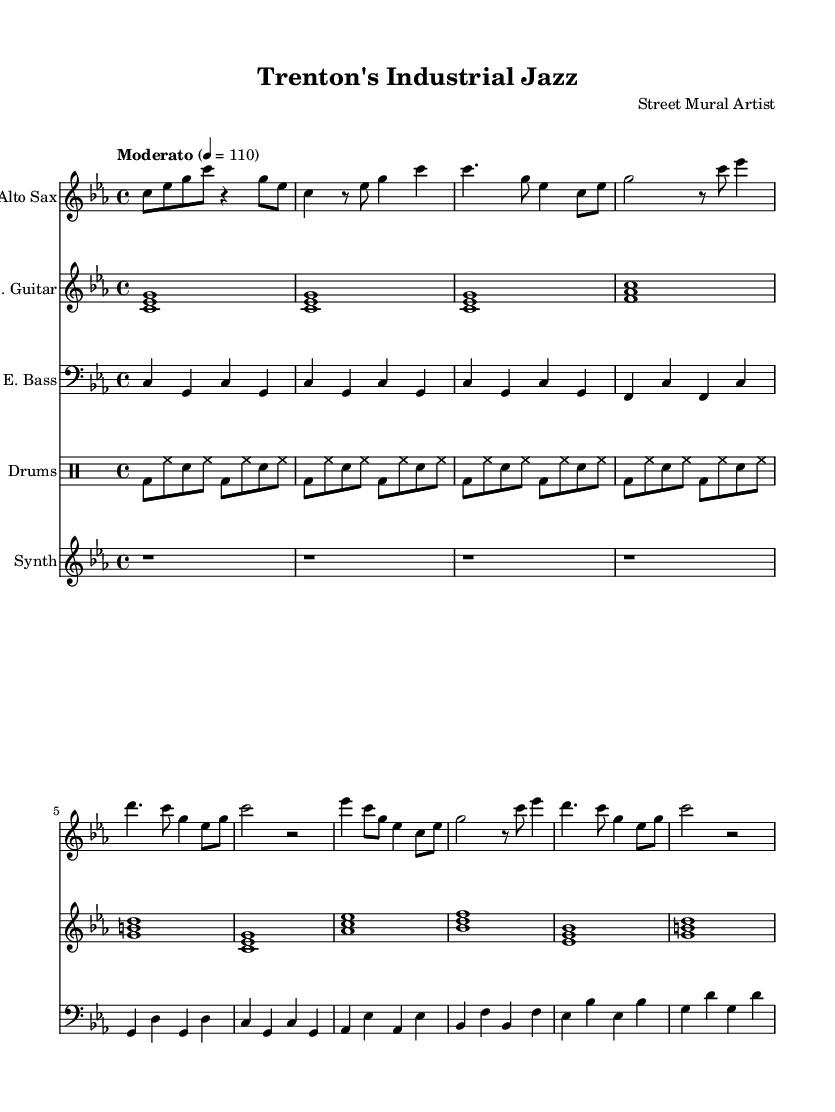what is the key signature of this music? The key signature is C minor, as indicated by the flat symbols on the staff for B flat, E flat, and A flat.
Answer: C minor what is the time signature of this music? The time signature shown at the beginning of the score is 4/4, which means there are four beats in each measure and the quarter note gets one beat.
Answer: 4/4 what is the tempo indication for this piece? The tempo indication says "Moderato" with a metronome marking of 110, which means to play at a moderate speed of 110 beats per minute.
Answer: Moderato how many sections are there in the piece? The piece includes an intro, verse, and chorus, comprising a total of three distinct sections.
Answer: 3 what instruments are featured in this score? The score includes Alto Sax, Electric Guitar, Electric Bass, Drums, and Synthesizer as the listed instruments on the score.
Answer: Alto Sax, Electric Guitar, Electric Bass, Drums, Synthesizer which beat pattern is used for the drums? The drum part features a funk-inspired pattern consisting of bass drum, hi-hat, and snare with a consistent rhythm across measures.
Answer: Funk-inspired what is the overall character of the music based on its title? The title "Trenton's Industrial Jazz" implies the music combines elements of jazz with influences from industrial sounds, reflective of Trenton's history.
Answer: Industrial Jazz 